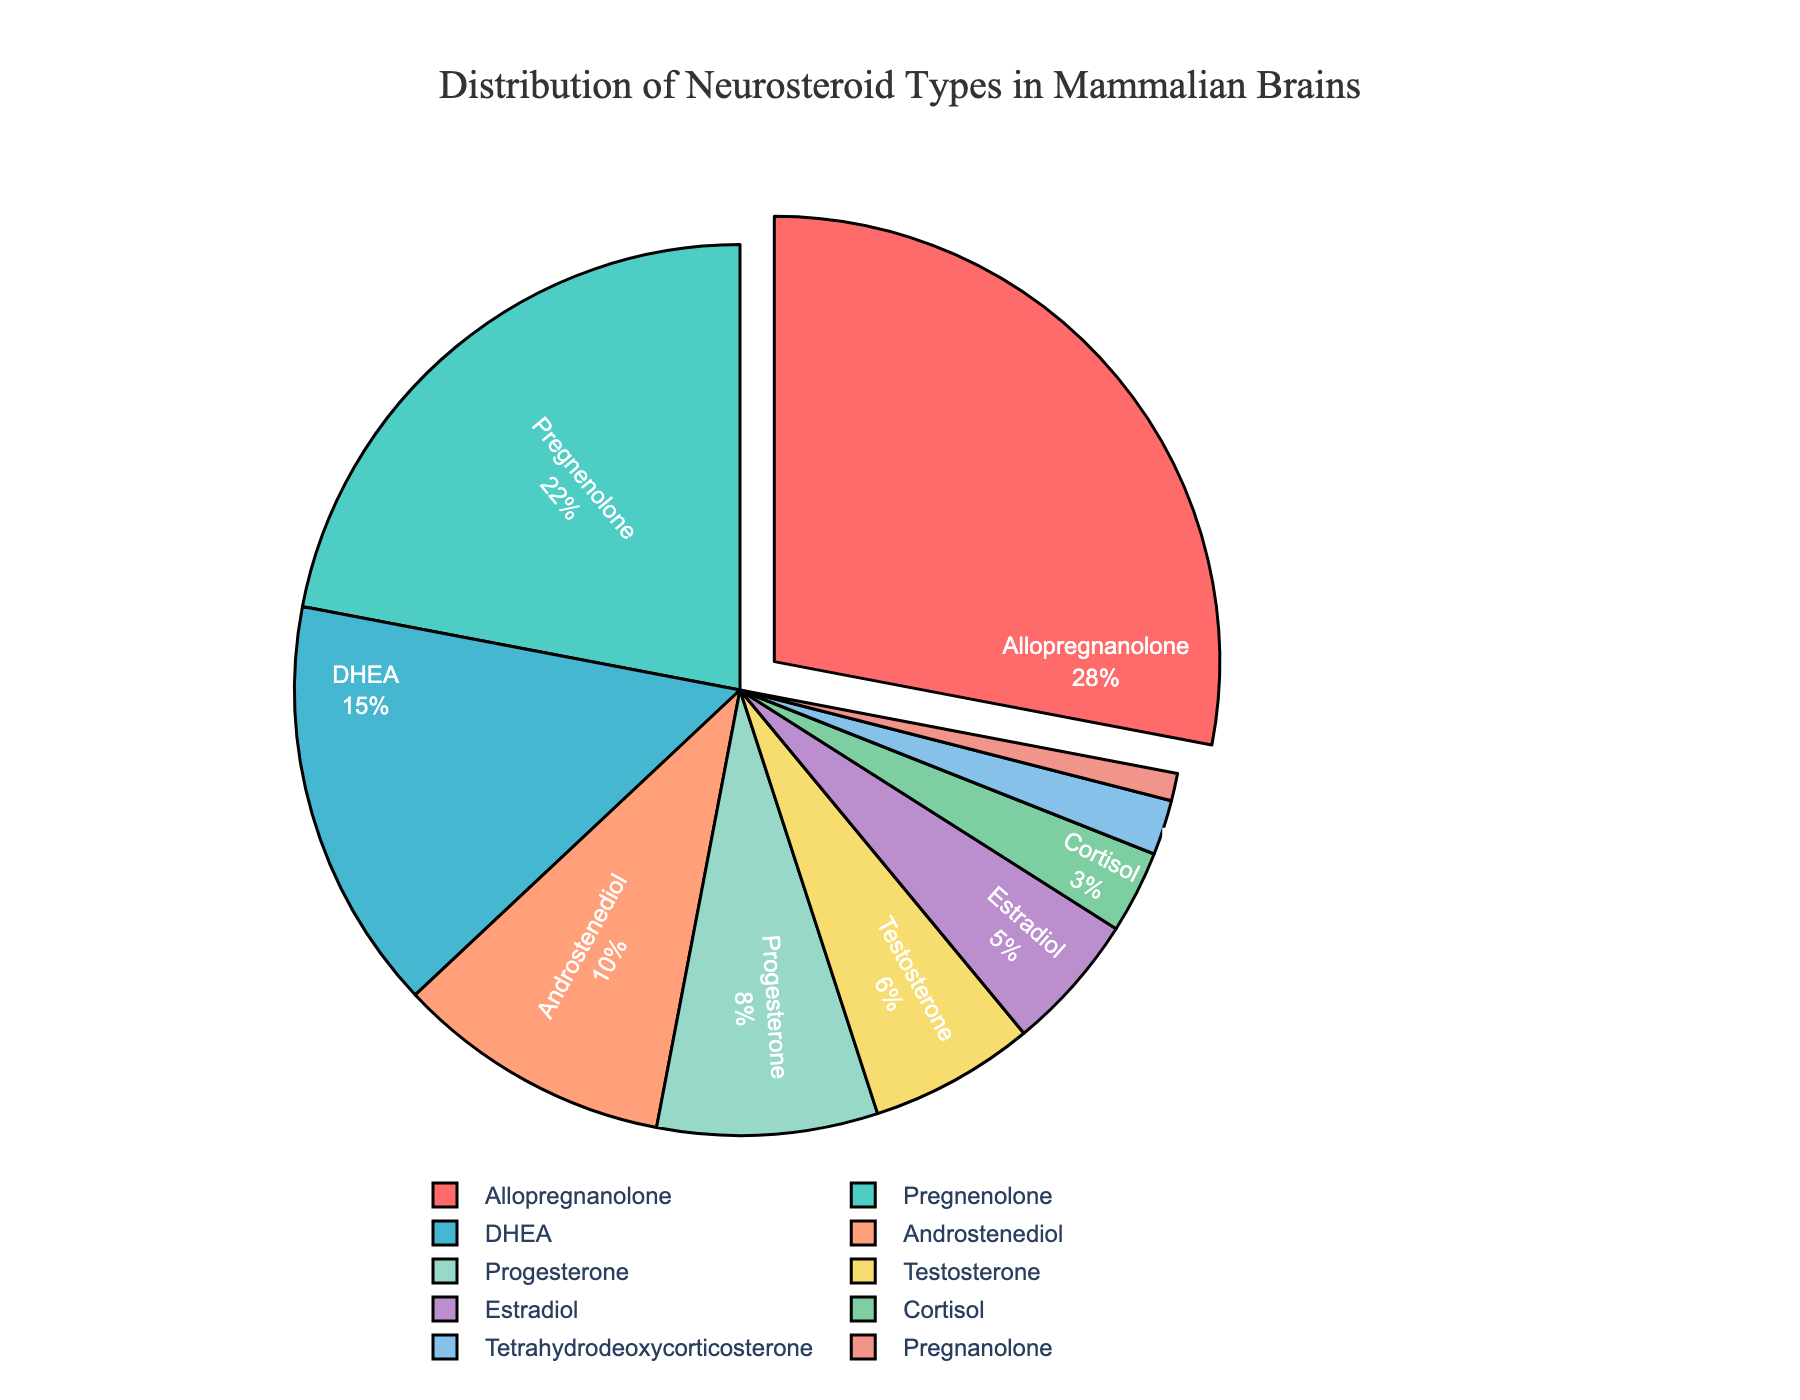Which neurosteroid has the highest percentage in mammalian brains? The figure indicates which neurosteroid has the largest section of the pie chart. The neurosteroid with the largest percentage will be visually pulled out from the pie.
Answer: Allopregnanolone What is the total percentage of Pregnenolone and DHEA combined? To find the combined total, add the percentage values for Pregnenolone and DHEA: 22% (Pregnenolone) + 15% (DHEA).
Answer: 37% Which neurosteroid has a smaller percentage, Testosterone or Estradiol? Compare the percentage values for Testosterone (6%) and Estradiol (5%). The one with the smaller value has a smaller percentage.
Answer: Estradiol How much more prevalent is Allopregnanolone compared to Androstenediol? Subtract the percentage of Androstenediol (10%) from the percentage of Allopregnanolone (28%) to find the difference.
Answer: 18% What is the cumulative percentage of neurosteroids with less than 5% each? Summing the percentages of neurosteroids less than 5%: Cortisol (3%) + Tetrahydrodeoxycorticosterone (2%) + Pregnanolone (1%).
Answer: 6% If you combine Progesterone and Estradiol, what would their total percentage be? Add the percentage values for Progesterone and Estradiol: 8% (Progesterone) + 5% (Estradiol).
Answer: 13% Which neurosteroid type is represented by the green section of the pie chart? Identify the neurosteroid category based on the color of the sections in the pie chart. The green section corresponds to the legend provided.
Answer: Pregnenolone Which neurosteroid types account for more than half of the total percentage? Identify the neurosteroids whose individual percentages sum to more than 50%. Sum each percentage sequentially until it exceeds 50%. Allopregnanolone (28%) + Pregnenolone (22%) + DHEA (15%).
Answer: Allopregnanolone, Pregnenolone, DHEA Is Androstenediol more than twice the percentage of Tetrahydrodeoxycorticosterone? Compare twice the percentage of Tetrahydrodeoxycorticosterone (2%) to that of Androstenediol (10%). 2 * 2% = 4%, and 10% > 4%.
Answer: Yes 